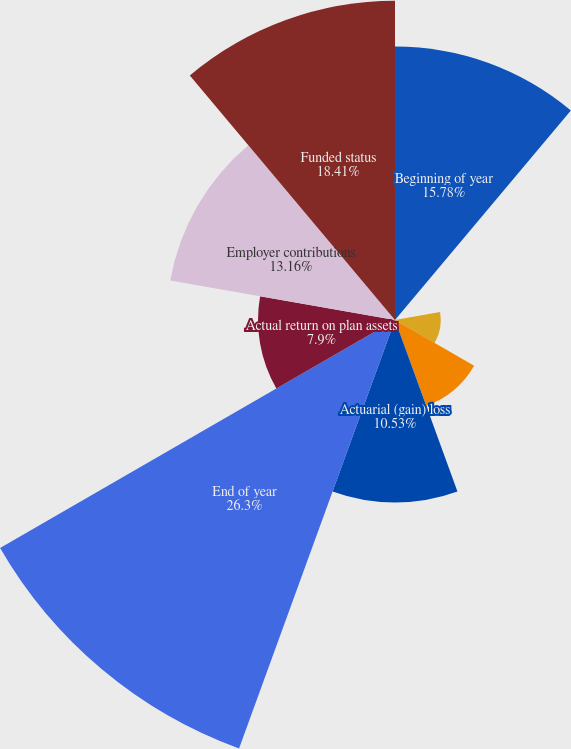Convert chart. <chart><loc_0><loc_0><loc_500><loc_500><pie_chart><fcel>Beginning of year<fcel>Service cost<fcel>Interest cost<fcel>Benefits paid<fcel>Actuarial (gain) loss<fcel>End of year<fcel>Actual return on plan assets<fcel>Employer contributions<fcel>Funded status<nl><fcel>15.78%<fcel>0.01%<fcel>2.64%<fcel>5.27%<fcel>10.53%<fcel>26.3%<fcel>7.9%<fcel>13.16%<fcel>18.41%<nl></chart> 